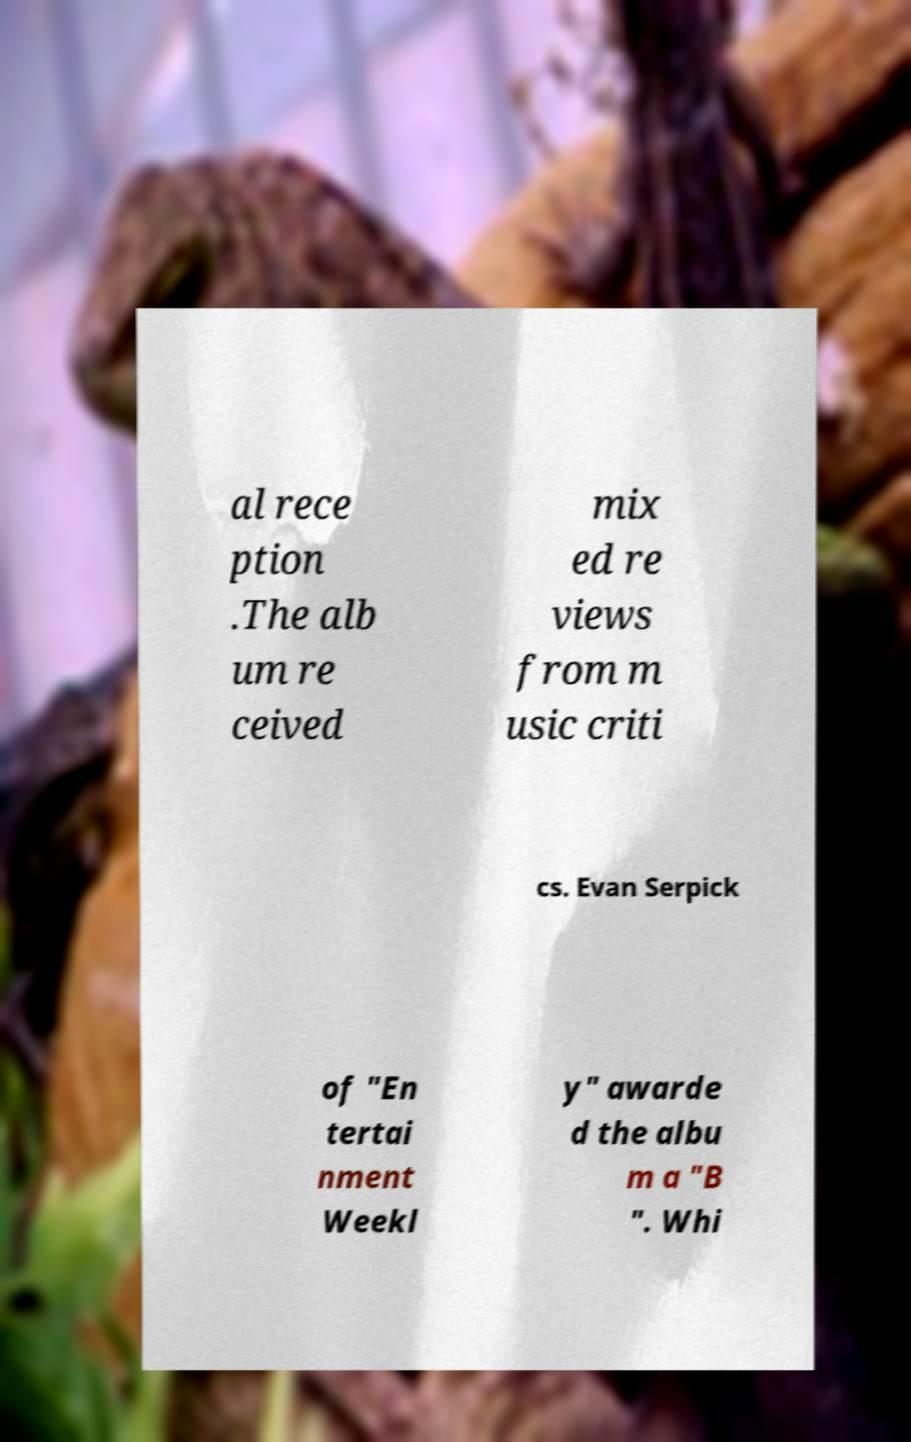Could you assist in decoding the text presented in this image and type it out clearly? al rece ption .The alb um re ceived mix ed re views from m usic criti cs. Evan Serpick of "En tertai nment Weekl y" awarde d the albu m a "B ". Whi 